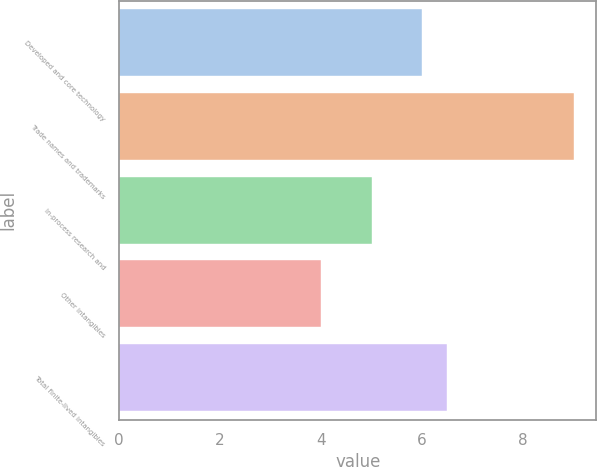Convert chart. <chart><loc_0><loc_0><loc_500><loc_500><bar_chart><fcel>Developed and core technology<fcel>Trade names and trademarks<fcel>In-process research and<fcel>Other intangibles<fcel>Total finite-lived intangibles<nl><fcel>6<fcel>9<fcel>5<fcel>4<fcel>6.5<nl></chart> 